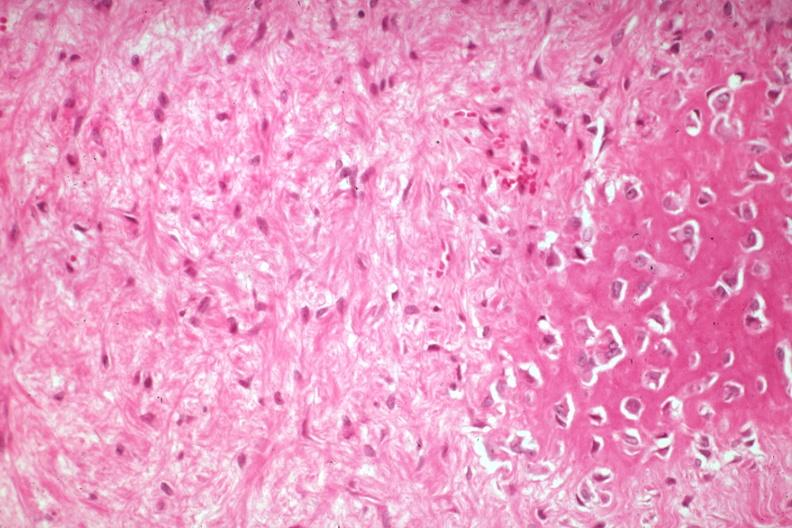s joints present?
Answer the question using a single word or phrase. Yes 